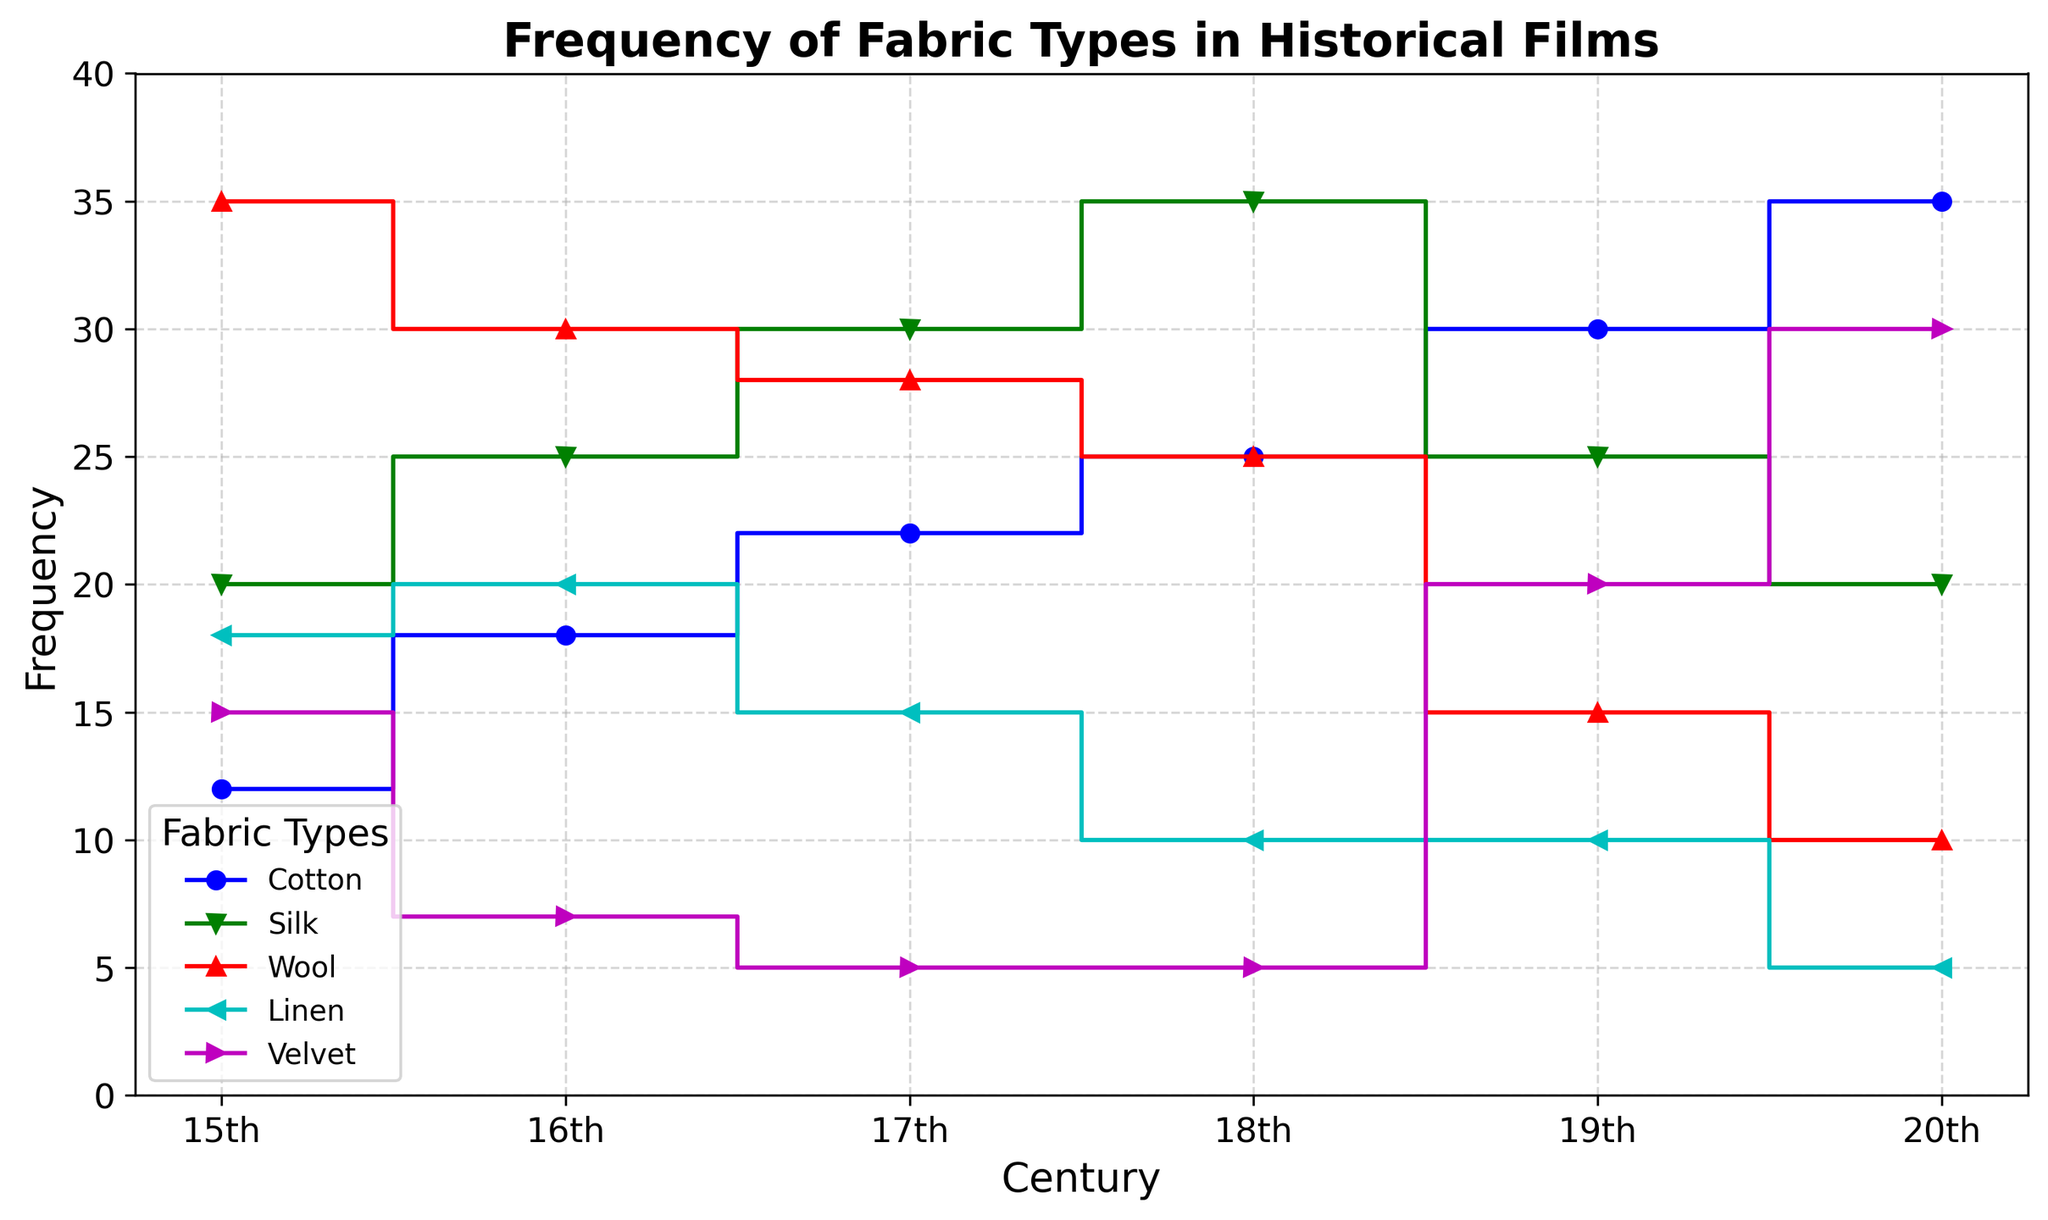What is the overall trend in the frequency of Cotton usage from the 15th to the 20th century? The trend in cotton usage shows a consistent increase from 12 in the 15th century to 35 in the 20th century. This indicates that the use of cotton became more common over time.
Answer: Increase Which fabric type had the highest frequency in the 15th century, and what was it? Looking at the values for the 15th century, wool had the highest frequency with a count of 35.
Answer: Wool, 35 How did the frequency of Velvet usage change from the 16th century to the 19th century? In the 16th century, the frequency of velvet was 7. It decreased to 5 in both the 17th and 18th centuries and then rose sharply to 20 in the 19th century.
Answer: Decreased, then increased Between which two consecutive centuries did Silk see the largest increase in frequency? Comparing the frequencies: 20 (15th) to 25 (16th) is an increase of 5, 25 (16th) to 30 (17th) is an increase of 5, 30 (17th) to 35 (18th) is an increase of 5, and 35 (18th) to 25 (19th) is a decrease of 10. Therefore, the largest increase is between the 17th and 18th centuries.
Answer: 17th and 18th centuries What is the sum of the frequencies for Wool and Velvet in the 20th century? The frequency of wool in the 20th century is 10, and for velvet, it is 30. Summing these values gives 10 + 30 = 40.
Answer: 40 Which century showed the highest frequency for Silk, and what was the frequency? Examining the data, the highest frequency for Silk is in the 18th century with a count of 35.
Answer: 18th century, 35 How does the frequency of Linen usage compare between the 15th and the 20th centuries? In the 15th century, the frequency of linen was 18. By the 20th century, it decreased to 5. This indicates a significant reduction.
Answer: Decreased Is there any century where the frequency of Cotton is higher than that of Wool? Yes, from the 18th century onwards, the frequency of cotton is 25 and increasing, while wool declines below cotton's frequency in each of these centuries.
Answer: Yes What’s the average frequency of Velvet across all six centuries? Adding the frequencies of velvet (15 + 7 + 5 + 5 + 20 + 30) gives 82. Dividing by 6 centuries, the average is 82 / 6 ≈ 13.67.
Answer: 13.67 In which century do we see the smallest frequency for Wool, and what value is it? The smallest frequency for Wool is in the 20th century with a count of 10.
Answer: 20th century, 10 